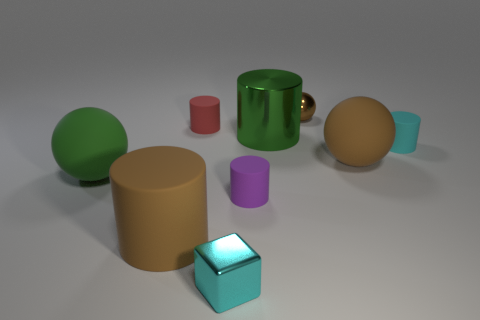How many brown balls must be subtracted to get 1 brown balls? 1 Add 1 tiny purple cylinders. How many objects exist? 10 Subtract all big green metallic cylinders. How many cylinders are left? 4 Subtract all spheres. How many objects are left? 6 Add 7 small cyan metal cubes. How many small cyan metal cubes exist? 8 Subtract all purple cylinders. How many cylinders are left? 4 Subtract 0 blue spheres. How many objects are left? 9 Subtract 3 cylinders. How many cylinders are left? 2 Subtract all yellow cylinders. Subtract all gray balls. How many cylinders are left? 5 Subtract all brown spheres. How many red blocks are left? 0 